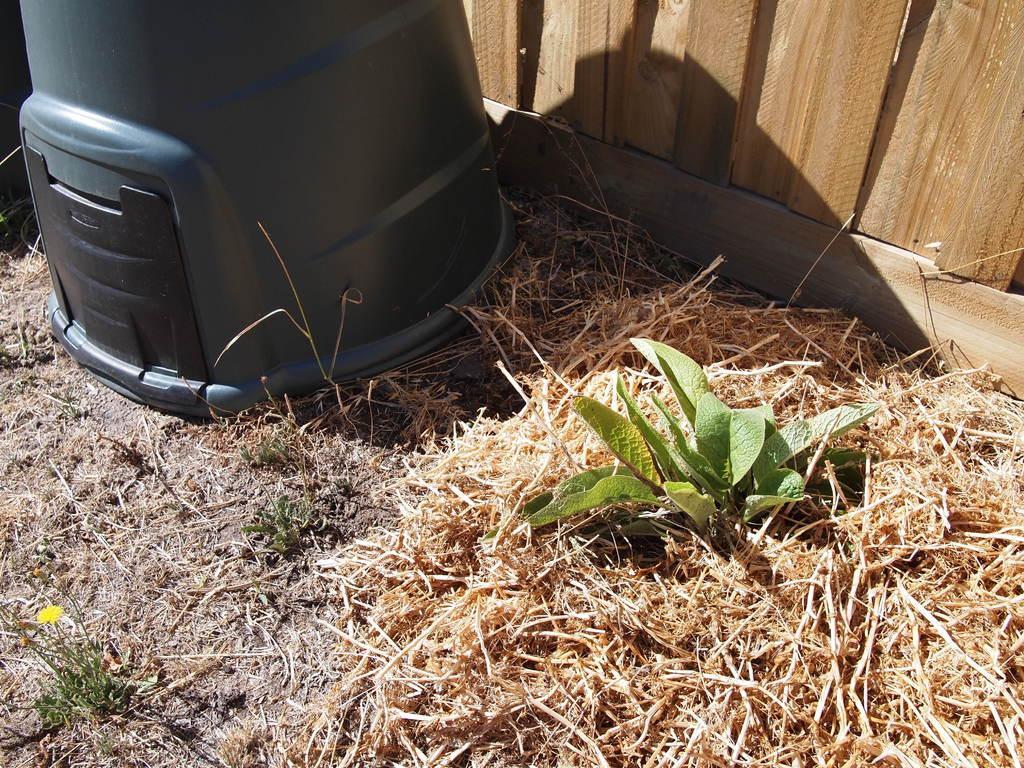Could you give a brief overview of what you see in this image? At the bottom of the image there is grass on the ground. At the top left corner of the image there is a black item. At the right top corner of the image there is a wooden wall. 